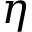Convert formula to latex. <formula><loc_0><loc_0><loc_500><loc_500>\eta</formula> 